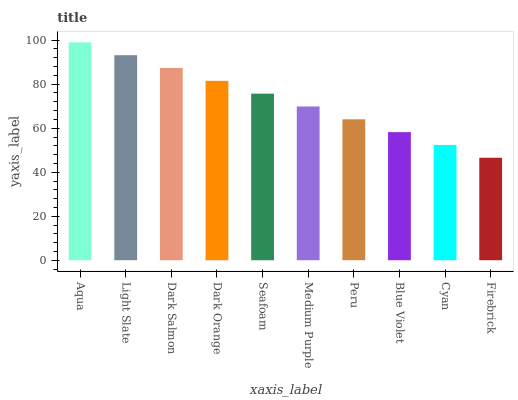Is Aqua the maximum?
Answer yes or no. Yes. Is Light Slate the minimum?
Answer yes or no. No. Is Light Slate the maximum?
Answer yes or no. No. Is Aqua greater than Light Slate?
Answer yes or no. Yes. Is Light Slate less than Aqua?
Answer yes or no. Yes. Is Light Slate greater than Aqua?
Answer yes or no. No. Is Aqua less than Light Slate?
Answer yes or no. No. Is Seafoam the high median?
Answer yes or no. Yes. Is Medium Purple the low median?
Answer yes or no. Yes. Is Cyan the high median?
Answer yes or no. No. Is Blue Violet the low median?
Answer yes or no. No. 